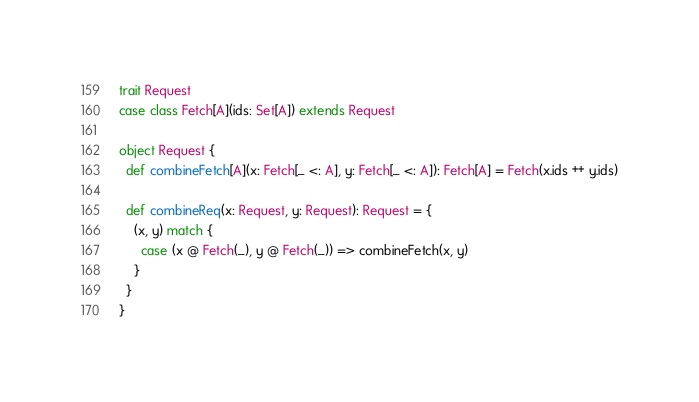<code> <loc_0><loc_0><loc_500><loc_500><_Scala_>trait Request
case class Fetch[A](ids: Set[A]) extends Request

object Request {
  def combineFetch[A](x: Fetch[_ <: A], y: Fetch[_ <: A]): Fetch[A] = Fetch(x.ids ++ y.ids)

  def combineReq(x: Request, y: Request): Request = {
    (x, y) match {
      case (x @ Fetch(_), y @ Fetch(_)) => combineFetch(x, y)
    }
  }
}
</code> 